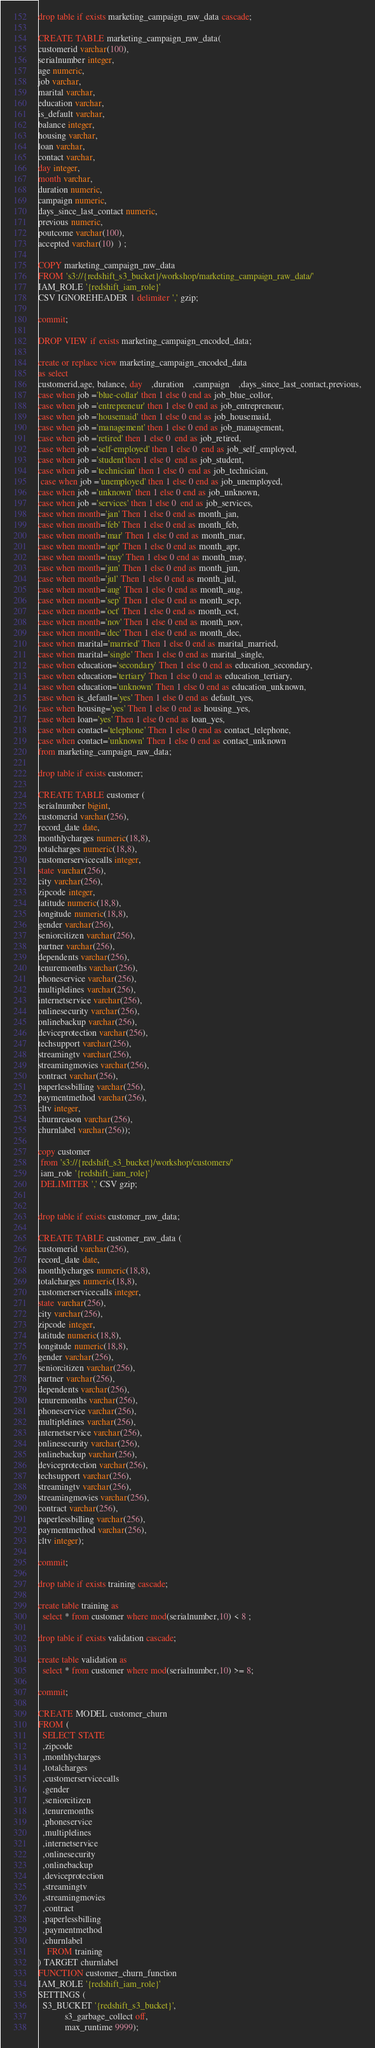<code> <loc_0><loc_0><loc_500><loc_500><_SQL_>drop table if exists marketing_campaign_raw_data cascade;

CREATE TABLE marketing_campaign_raw_data(
customerid varchar(100),
serialnumber integer,
age numeric,
job varchar,
marital varchar,
education varchar,
is_default varchar,
balance integer,
housing varchar,
loan varchar,
contact varchar,
day integer,
month varchar,
duration numeric,
campaign numeric,
days_since_last_contact numeric,
previous numeric,
poutcome varchar(100),
accepted varchar(10)  ) ;

COPY marketing_campaign_raw_data
FROM 's3://{redshift_s3_bucket}/workshop/marketing_campaign_raw_data/'
IAM_ROLE '{redshift_iam_role}'
CSV IGNOREHEADER 1 delimiter ',' gzip;

commit;

DROP VIEW if exists marketing_campaign_encoded_data;

create or replace view marketing_campaign_encoded_data
as select
customerid,age, balance, day	,duration	,campaign	,days_since_last_contact,previous,
case when job ='blue-collar' then 1 else 0 end as job_blue_collor,
case when job ='entrepreneur' then 1 else 0 end as job_entrepreneur,
case when job ='housemaid' then 1 else 0 end as job_housemaid,
case when job ='management' then 1 else 0 end as job_management,
case when job ='retired' then 1 else 0  end as job_retired,
case when job ='self-employed' then 1 else 0  end as job_self_employed,
case when job ='student'then 1 else 0  end as job_student,
case when job ='technician' then 1 else 0  end as job_technician,
 case when job ='unemployed' then 1 else 0 end as job_unemployed,
case when job ='unknown' then 1 else 0 end as job_unknown,
case when job ='services' then 1 else 0  end as job_services,
case when month='jan' Then 1 else 0 end as month_jan,
case when month='feb' Then 1 else 0 end as month_feb,
case when month='mar' Then 1 else 0 end as month_mar,
case when month='apr' Then 1 else 0 end as month_apr,
case when month='may' Then 1 else 0 end as month_may,
case when month='jun' Then 1 else 0 end as month_jun,
case when month='jul' Then 1 else 0 end as month_jul,
case when month='aug' Then 1 else 0 end as month_aug,
case when month='sep' Then 1 else 0 end as month_sep,
case when month='oct' Then 1 else 0 end as month_oct,
case when month='nov' Then 1 else 0 end as month_nov,
case when month='dec' Then 1 else 0 end as month_dec,
case when marital='married' Then 1 else 0 end as marital_married,
case when marital='single' Then 1 else 0 end as marital_single,
case when education='secondary' Then 1 else 0 end as education_secondary,
case when education='tertiary' Then 1 else 0 end as education_tertiary,
case when education='unknown' Then 1 else 0 end as education_unknown,
case when is_default='yes' Then 1 else 0 end as default_yes,
case when housing='yes' Then 1 else 0 end as housing_yes,
case when loan='yes' Then 1 else 0 end as loan_yes,
case when contact='telephone' Then 1 else 0 end as contact_telephone,
case when contact='unknown' Then 1 else 0 end as contact_unknown
from marketing_campaign_raw_data;

drop table if exists customer;

CREATE TABLE customer (
serialnumber bigint,
customerid varchar(256),
record_date date,
monthlycharges numeric(18,8),
totalcharges numeric(18,8),
customerservicecalls integer,
state varchar(256),
city varchar(256),
zipcode integer,
latitude numeric(18,8),
longitude numeric(18,8),
gender varchar(256),
seniorcitizen varchar(256),
partner varchar(256),
dependents varchar(256),
tenuremonths varchar(256),
phoneservice varchar(256),
multiplelines varchar(256),
internetservice varchar(256),
onlinesecurity varchar(256),
onlinebackup varchar(256),
deviceprotection varchar(256),
techsupport varchar(256),
streamingtv varchar(256),
streamingmovies varchar(256),
contract varchar(256),
paperlessbilling varchar(256),
paymentmethod varchar(256),
cltv integer,
churnreason varchar(256),
churnlabel varchar(256));

copy customer
 from 's3://{redshift_s3_bucket}/workshop/customers/'
 iam_role '{redshift_iam_role}'
 DELIMITER ',' CSV gzip;


drop table if exists customer_raw_data;

CREATE TABLE customer_raw_data (
customerid varchar(256),
record_date date,
monthlycharges numeric(18,8),
totalcharges numeric(18,8),
customerservicecalls integer,
state varchar(256),
city varchar(256),
zipcode integer,
latitude numeric(18,8),
longitude numeric(18,8),
gender varchar(256),
seniorcitizen varchar(256),
partner varchar(256),
dependents varchar(256),
tenuremonths varchar(256),
phoneservice varchar(256),
multiplelines varchar(256),
internetservice varchar(256),
onlinesecurity varchar(256),
onlinebackup varchar(256),
deviceprotection varchar(256),
techsupport varchar(256),
streamingtv varchar(256),
streamingmovies varchar(256),
contract varchar(256),
paperlessbilling varchar(256),
paymentmethod varchar(256),
cltv integer);

commit;

drop table if exists training cascade;

create table training as
  select * from customer where mod(serialnumber,10) < 8 ;

drop table if exists validation cascade;

create table validation as
  select * from customer where mod(serialnumber,10) >= 8;

commit;

CREATE MODEL customer_churn
FROM (
  SELECT STATE
  ,zipcode
  ,monthlycharges
  ,totalcharges
  ,customerservicecalls
  ,gender
  ,seniorcitizen
  ,tenuremonths
  ,phoneservice
  ,multiplelines
  ,internetservice
  ,onlinesecurity
  ,onlinebackup
  ,deviceprotection
  ,streamingtv
  ,streamingmovies
  ,contract
  ,paperlessbilling
  ,paymentmethod
  ,churnlabel
	FROM training
) TARGET churnlabel
FUNCTION customer_churn_function
IAM_ROLE '{redshift_iam_role}'
SETTINGS (
  S3_BUCKET '{redshift_s3_bucket}',
            s3_garbage_collect off,
            max_runtime 9999);
</code> 